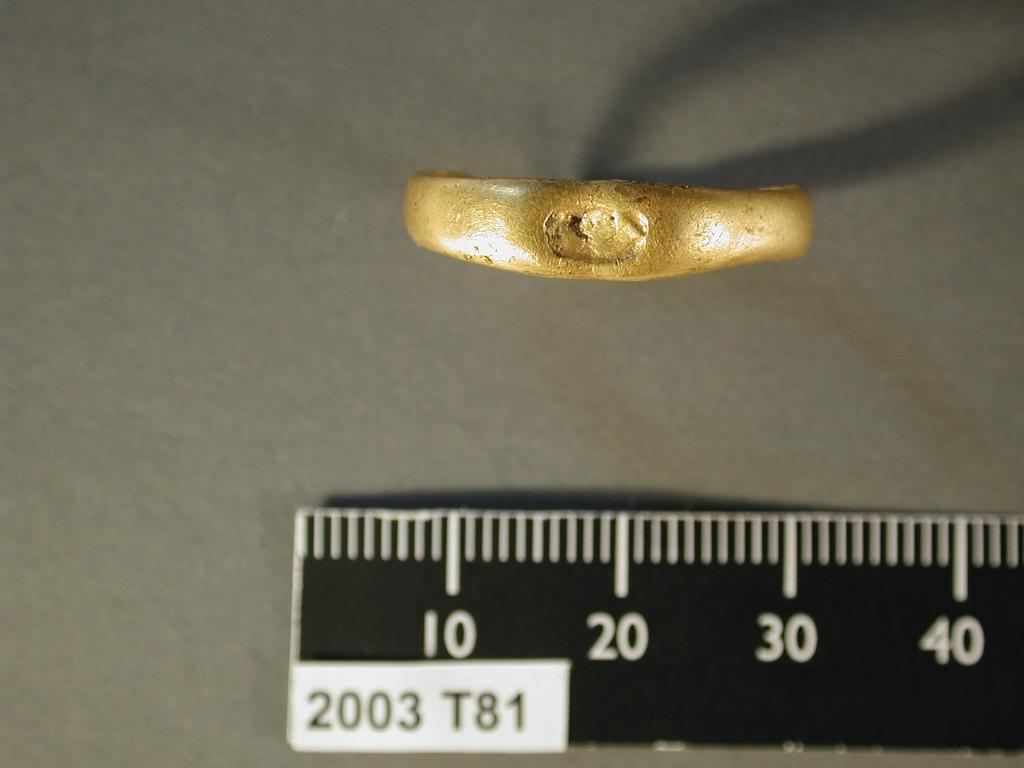<image>
Render a clear and concise summary of the photo. a small gold item placed near a ruler with numbers 10 20 30 and 40 shown 